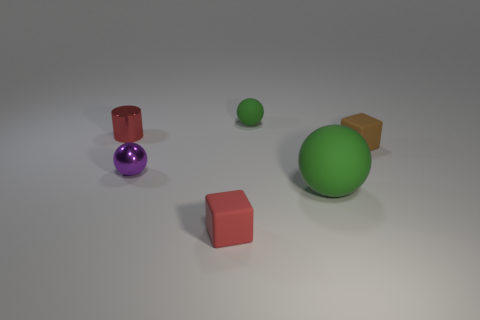Add 1 small yellow matte cylinders. How many objects exist? 7 Subtract all cylinders. How many objects are left? 5 Subtract 0 green cylinders. How many objects are left? 6 Subtract all small red matte objects. Subtract all big brown blocks. How many objects are left? 5 Add 6 large matte balls. How many large matte balls are left? 7 Add 1 tiny blue rubber cubes. How many tiny blue rubber cubes exist? 1 